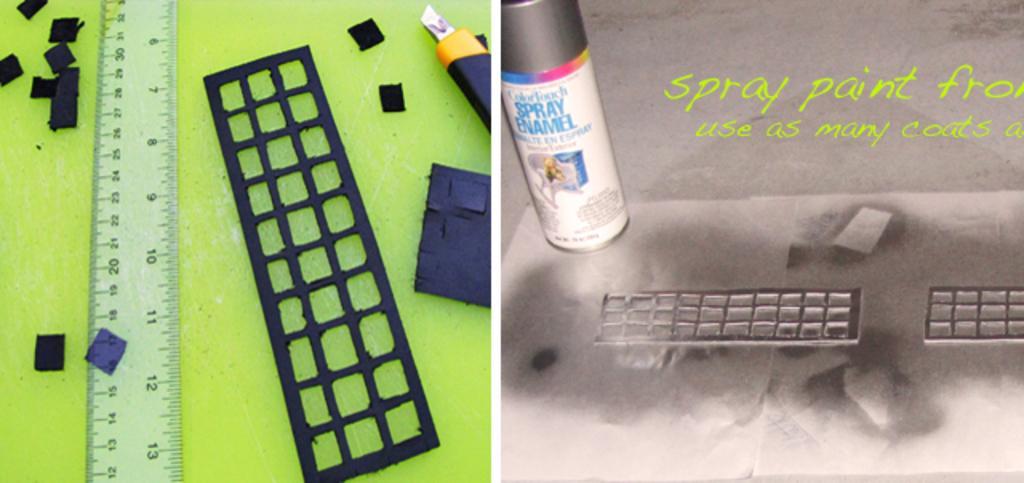Can you describe this image briefly? This image is collage of two different images. To left there are scales, pieces of paper and a cutter. To the right there is a bottle. There is text on the bottle. Beside the bottle there is text on the image. 